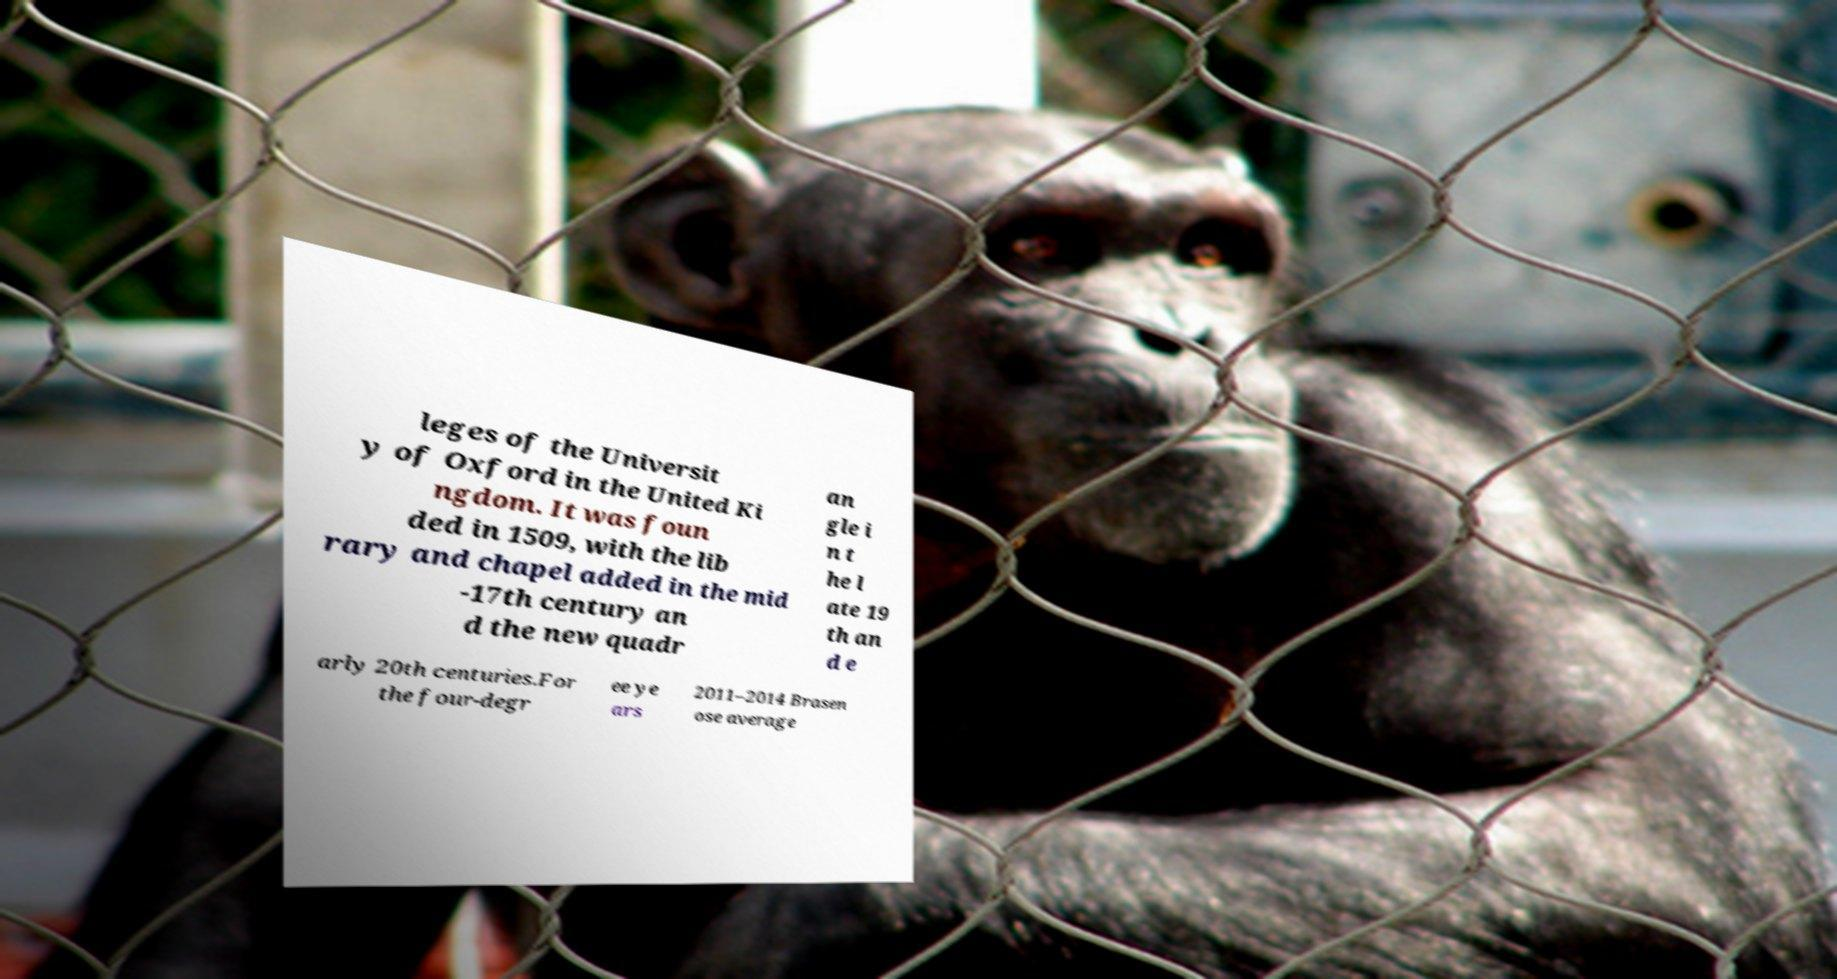Can you read and provide the text displayed in the image?This photo seems to have some interesting text. Can you extract and type it out for me? leges of the Universit y of Oxford in the United Ki ngdom. It was foun ded in 1509, with the lib rary and chapel added in the mid -17th century an d the new quadr an gle i n t he l ate 19 th an d e arly 20th centuries.For the four-degr ee ye ars 2011–2014 Brasen ose average 